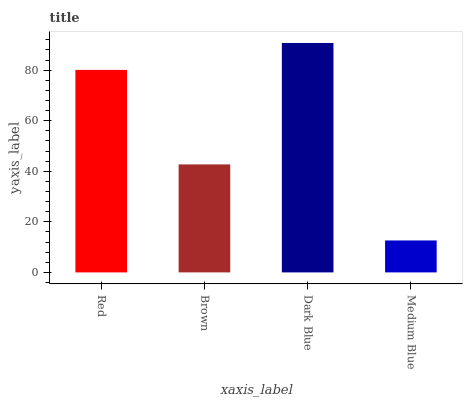Is Medium Blue the minimum?
Answer yes or no. Yes. Is Dark Blue the maximum?
Answer yes or no. Yes. Is Brown the minimum?
Answer yes or no. No. Is Brown the maximum?
Answer yes or no. No. Is Red greater than Brown?
Answer yes or no. Yes. Is Brown less than Red?
Answer yes or no. Yes. Is Brown greater than Red?
Answer yes or no. No. Is Red less than Brown?
Answer yes or no. No. Is Red the high median?
Answer yes or no. Yes. Is Brown the low median?
Answer yes or no. Yes. Is Dark Blue the high median?
Answer yes or no. No. Is Red the low median?
Answer yes or no. No. 